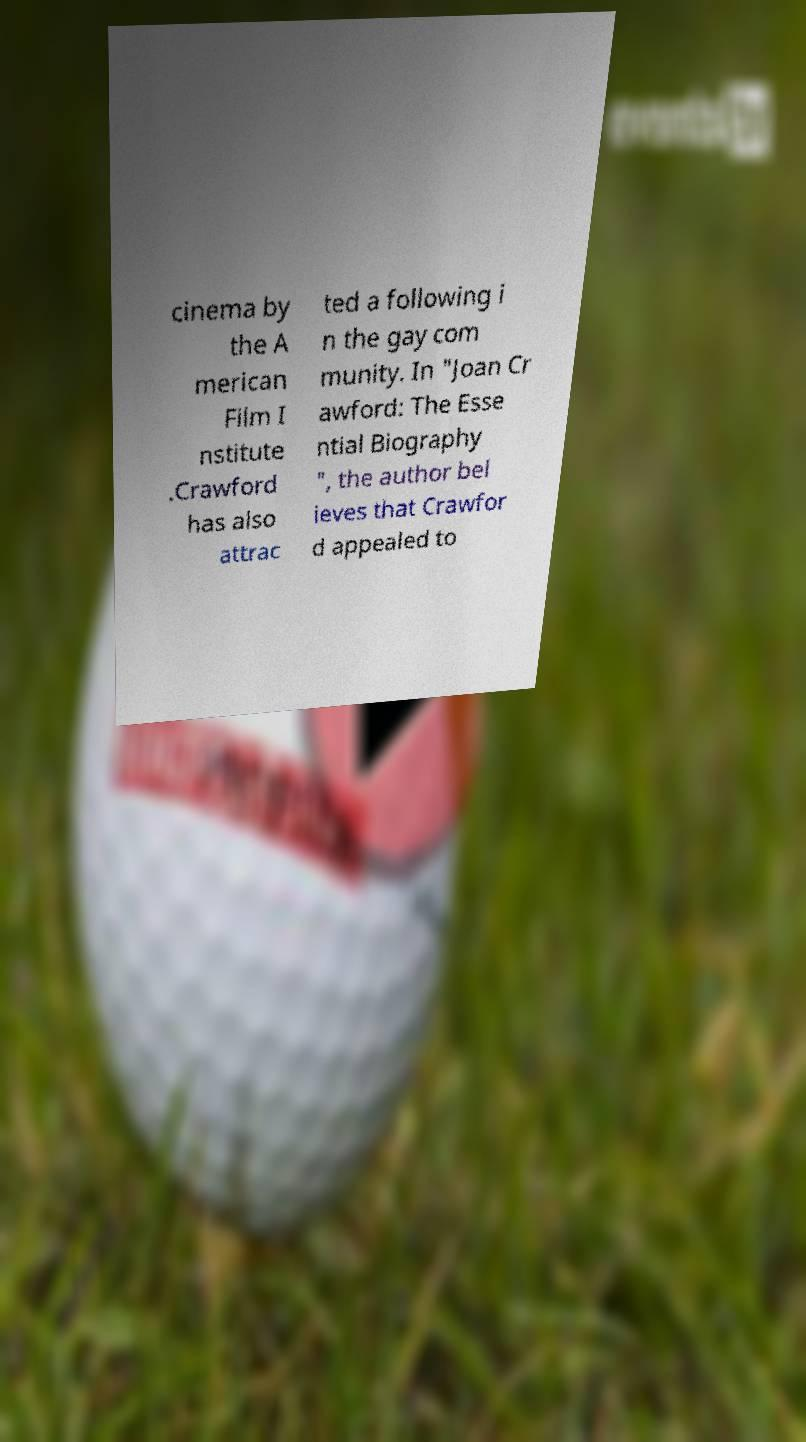Could you extract and type out the text from this image? cinema by the A merican Film I nstitute .Crawford has also attrac ted a following i n the gay com munity. In "Joan Cr awford: The Esse ntial Biography ", the author bel ieves that Crawfor d appealed to 